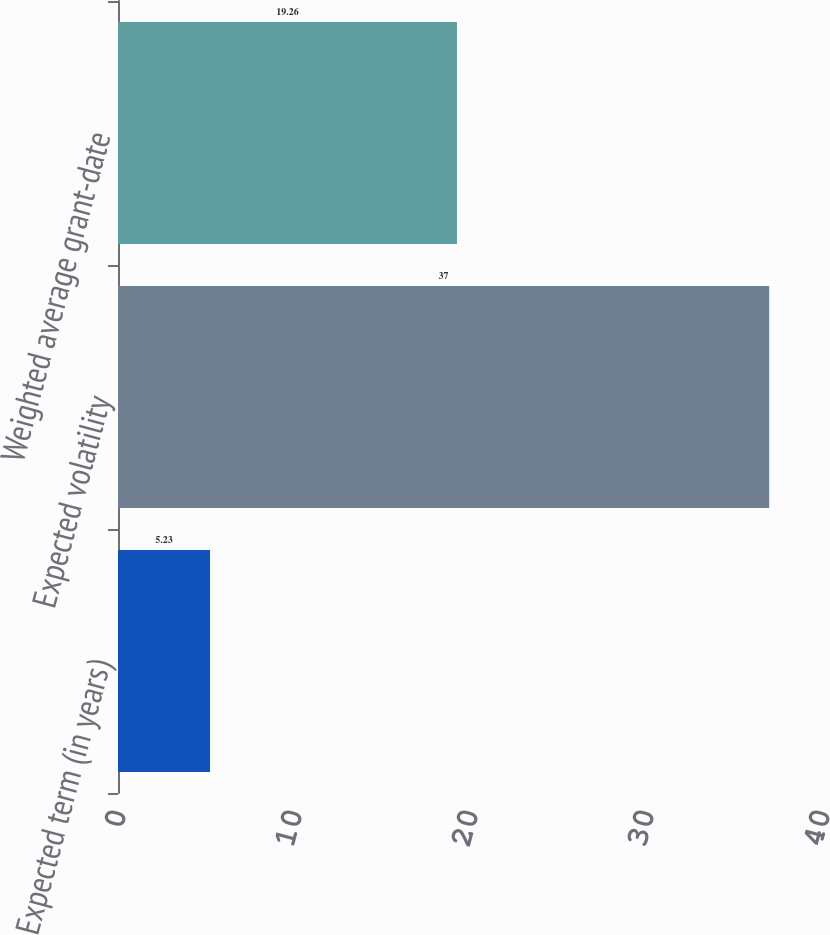<chart> <loc_0><loc_0><loc_500><loc_500><bar_chart><fcel>Expected term (in years)<fcel>Expected volatility<fcel>Weighted average grant-date<nl><fcel>5.23<fcel>37<fcel>19.26<nl></chart> 